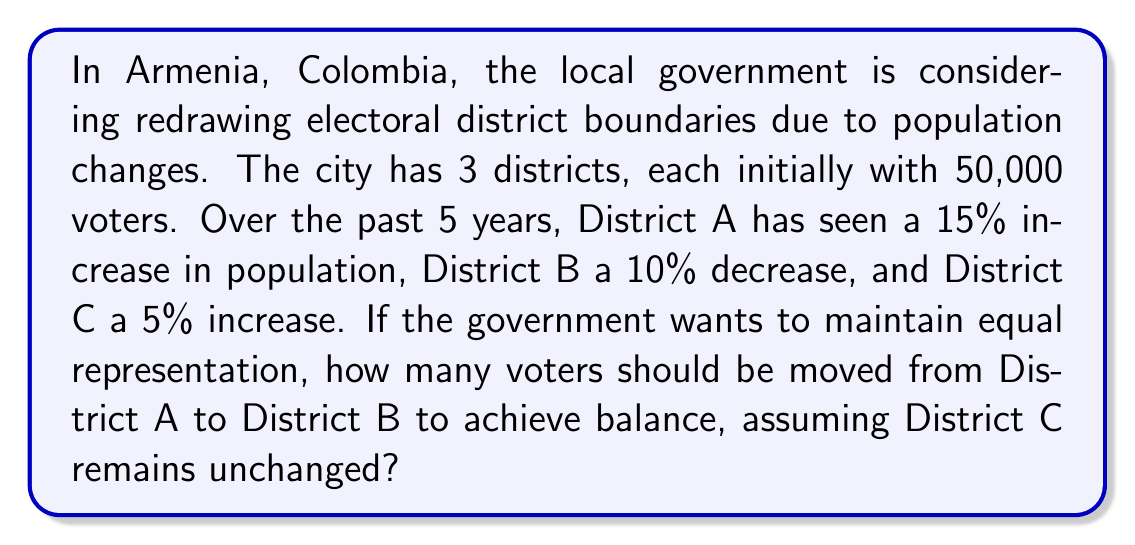Can you answer this question? Let's approach this problem step-by-step:

1. Calculate the new population of each district:
   District A: $50,000 \times (1 + 0.15) = 57,500$
   District B: $50,000 \times (1 - 0.10) = 45,000$
   District C: $50,000 \times (1 + 0.05) = 52,500$

2. Calculate the total population:
   $57,500 + 45,000 + 52,500 = 155,000$

3. For equal representation, each district should have:
   $\frac{155,000}{3} = 51,666.67$ voters (rounded to 2 decimal places)

4. District C is already close to this number, so we'll keep it unchanged.

5. To balance Districts A and B:
   - District A needs to decrease by: $57,500 - 51,666.67 = 5,833.33$
   - District B needs to increase by: $51,666.67 - 45,000 = 6,666.67$

6. The average of these two numbers will give us the number of voters to move:
   $\frac{5,833.33 + 6,666.67}{2} = 6,250$

Therefore, 6,250 voters should be moved from District A to District B.
Answer: 6,250 voters 